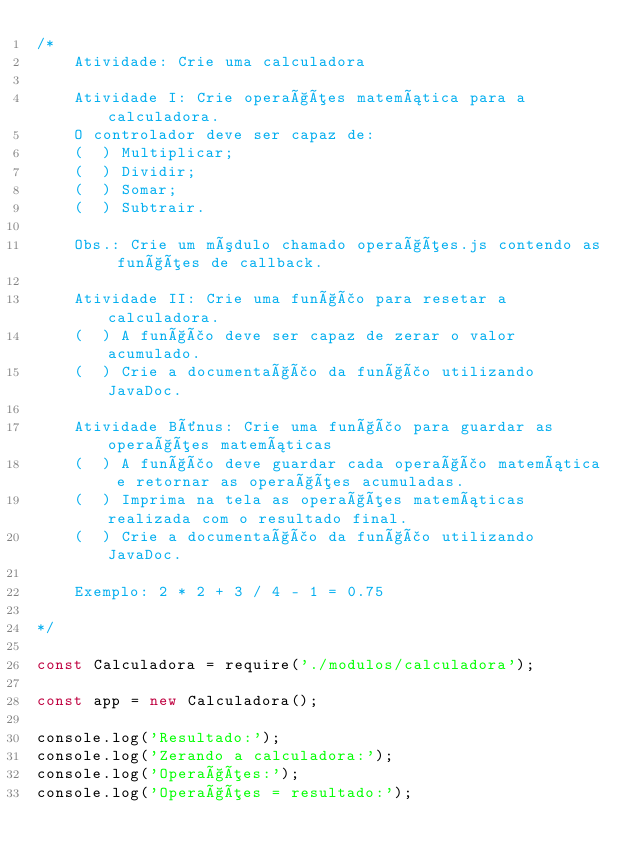<code> <loc_0><loc_0><loc_500><loc_500><_JavaScript_>/*
    Atividade: Crie uma calculadora

    Atividade I: Crie operações matemática para a calculadora.
    O controlador deve ser capaz de:
    (  ) Multiplicar;
    (  ) Dividir;
    (  ) Somar;
    (  ) Subtrair.
    
    Obs.: Crie um módulo chamado operações.js contendo as funções de callback.

    Atividade II: Crie uma função para resetar a calculadora.
    (  ) A função deve ser capaz de zerar o valor acumulado.
    (  ) Crie a documentação da função utilizando JavaDoc.

    Atividade Bônus: Crie uma função para guardar as operações matemáticas
    (  ) A função deve guardar cada operação matemática e retornar as operações acumuladas.
    (  ) Imprima na tela as operações matemáticas realizada com o resultado final.
    (  ) Crie a documentação da função utilizando JavaDoc.

    Exemplo: 2 * 2 + 3 / 4 - 1 = 0.75

*/

const Calculadora = require('./modulos/calculadora');

const app = new Calculadora();

console.log('Resultado:');
console.log('Zerando a calculadora:');
console.log('Operações:');
console.log('Operações = resultado:');</code> 